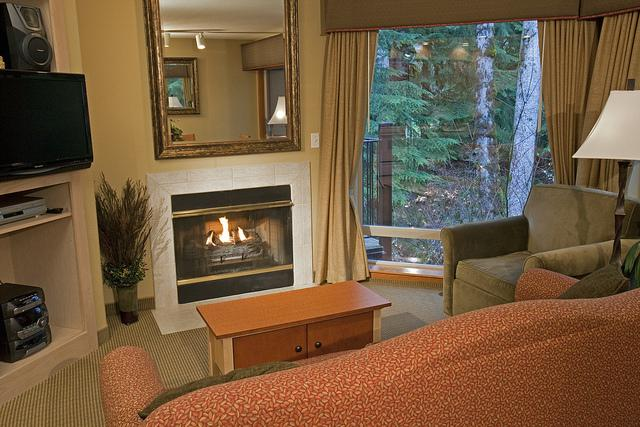What is the most likely floor level for this room? Please explain your reasoning. first/second. There is a deck just outside the window and they are only on these floors 